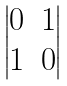Convert formula to latex. <formula><loc_0><loc_0><loc_500><loc_500>\begin{vmatrix} 0 & 1 \\ 1 & 0 \end{vmatrix}</formula> 